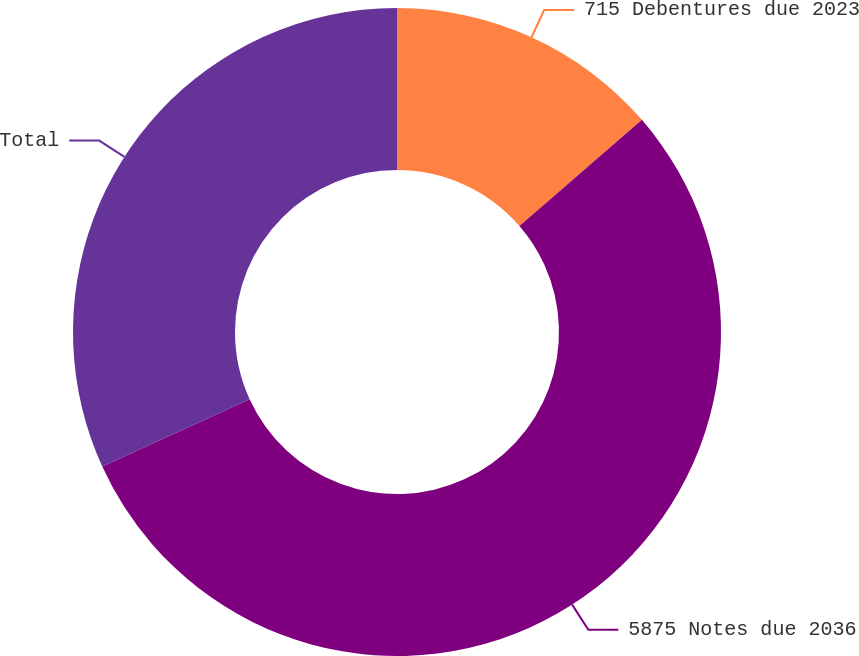<chart> <loc_0><loc_0><loc_500><loc_500><pie_chart><fcel>715 Debentures due 2023<fcel>5875 Notes due 2036<fcel>Total<nl><fcel>13.64%<fcel>54.55%<fcel>31.82%<nl></chart> 